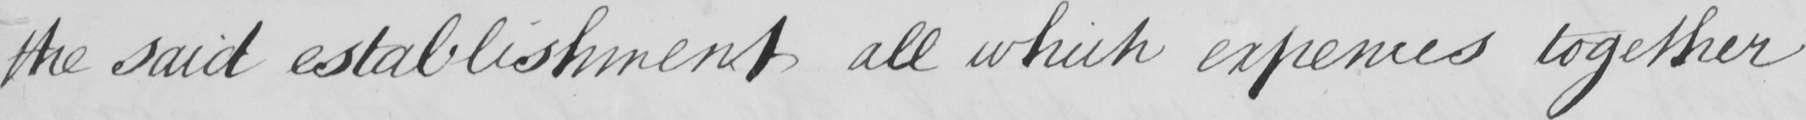Please provide the text content of this handwritten line. the said establishment all which expences together 